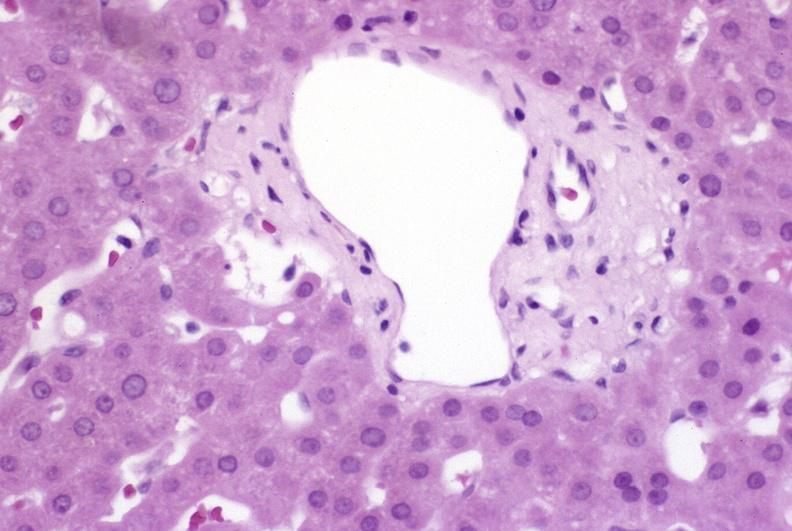s hypersegmented neutrophil present?
Answer the question using a single word or phrase. No 